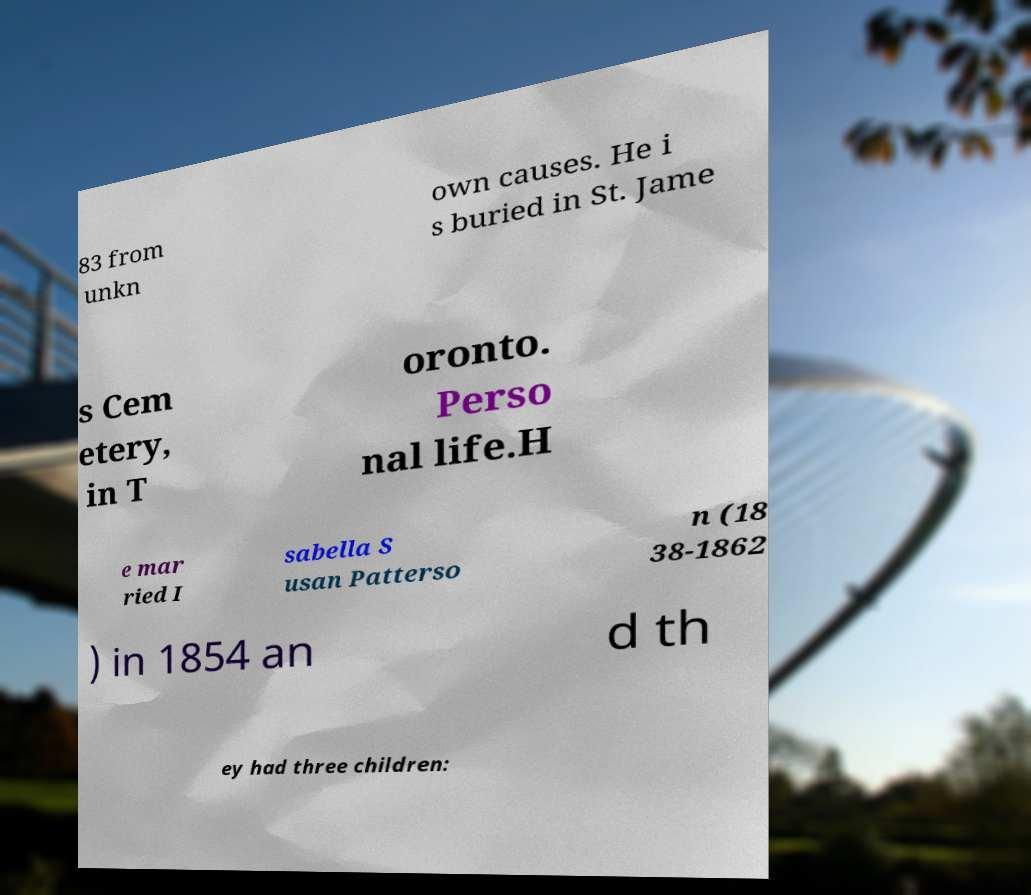For documentation purposes, I need the text within this image transcribed. Could you provide that? 83 from unkn own causes. He i s buried in St. Jame s Cem etery, in T oronto. Perso nal life.H e mar ried I sabella S usan Patterso n (18 38-1862 ) in 1854 an d th ey had three children: 